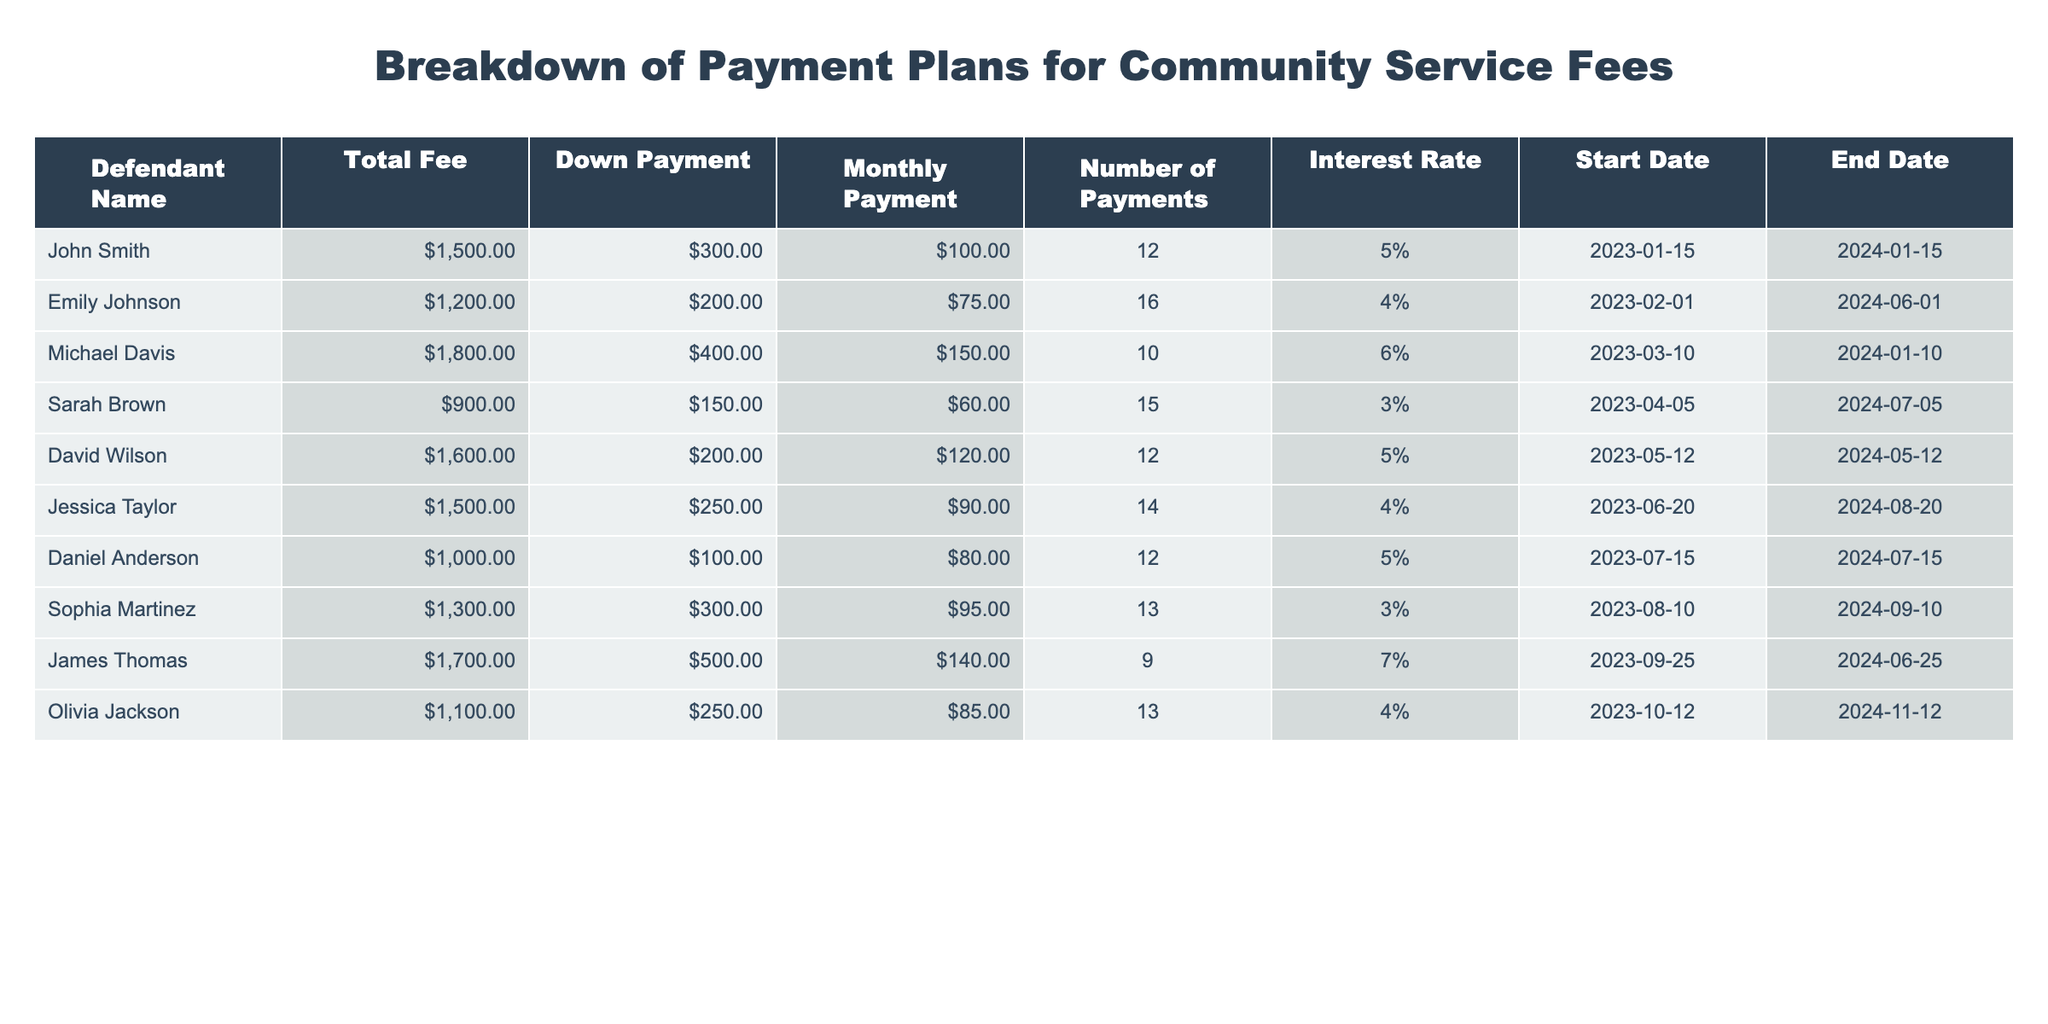What is the total fee for Sarah Brown? Sarah Brown's total fee is found in the "Total Fee" column of her row. Referring to the table, it states that her total fee is $900.
Answer: $900 What is the monthly payment amount for John Smith? John Smith's monthly payment can be found in the "Monthly Payment" column of his row. It shows that his monthly payment is $100.
Answer: $100 Is Emily Johnson's down payment greater than $250? To answer this question, we can check Emily Johnson's down payment in the "Down Payment" column. It shows that her down payment is $200, which is not greater than $250.
Answer: No What is the average interest rate for all defendants? To find the average interest rate, we look at the "Interest Rate" column. The rates are 5, 4, 6, 3, 5, 4, 5, 3, 7, and 4. Summing these rates gives 5 + 4 + 6 + 3 + 5 + 4 + 5 + 3 + 7 + 4 = 56. There are 10 defendants, so the average interest rate is 56/10 = 5.6.
Answer: 5.6 Which defendant has the highest total fee? In the "Total Fee" column, we identify the maximum value. Scanning through the amounts, Michael Davis has the highest fee at $1800.
Answer: Michael Davis How many total payments must David Wilson make? David Wilson's number of payments is located in the "Number of Payments" column. It states that he must make 12 payments.
Answer: 12 What is the total amount of down payments made by all defendants? To get the total down payments, we need to sum the "Down Payment" values from the table: $300 + $200 + $400 + $150 + $200 + $250 + $100 + $300 + $500 + $250 = $2850.
Answer: $2850 Do any defendants have a down payment of exactly $300? We review the "Down Payment" column to check for an exact match of $300. Sophia Martinez meets this criterion, as well as John Smith. Therefore, the answer is yes.
Answer: Yes What is the most common number of payments in this table? By examining the "Number of Payments" column, we see the occurrences: 12, 16, 10, 15, 12, 14, 12, 13, 9, 13. The number 12 appears three times, which is the highest frequency when compared to others.
Answer: 12 